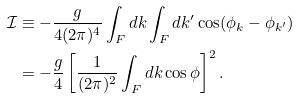Convert formula to latex. <formula><loc_0><loc_0><loc_500><loc_500>\mathcal { I } & \equiv - \frac { g } { 4 ( 2 \pi ) ^ { 4 } } \int _ { F } d k \int _ { F } d k ^ { \prime } \cos ( \phi _ { k } - \phi _ { k ^ { \prime } } ) \\ & = - \frac { g } { 4 } \left [ \frac { 1 } { ( 2 \pi ) ^ { 2 } } \int _ { F } d k \cos \phi \right ] ^ { 2 } .</formula> 